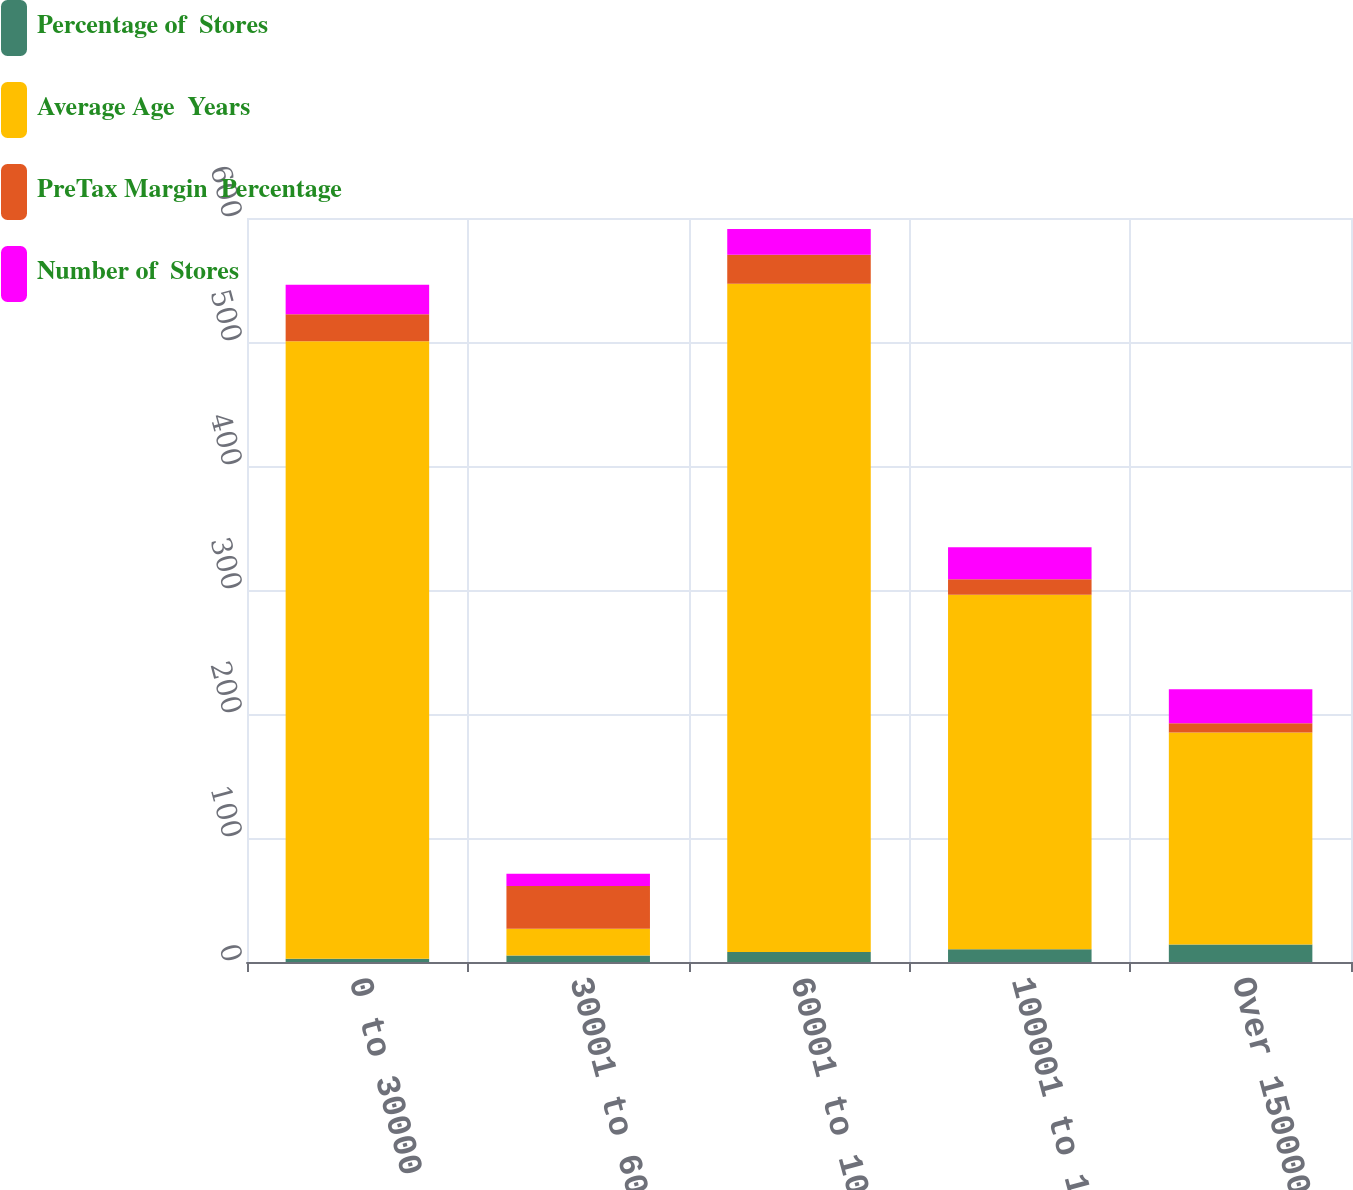Convert chart. <chart><loc_0><loc_0><loc_500><loc_500><stacked_bar_chart><ecel><fcel>0 to 30000<fcel>30001 to 60000<fcel>60001 to 100000<fcel>100001 to 150000<fcel>Over 150000<nl><fcel>Percentage of  Stores<fcel>2.7<fcel>5.3<fcel>8<fcel>10.2<fcel>14.1<nl><fcel>Average Age  Years<fcel>498<fcel>21.6<fcel>539<fcel>286<fcel>171<nl><fcel>PreTax Margin  Percentage<fcel>21.6<fcel>34.4<fcel>23.3<fcel>12.4<fcel>7.4<nl><fcel>Number of  Stores<fcel>23.9<fcel>9.9<fcel>20.9<fcel>25.9<fcel>27.4<nl></chart> 